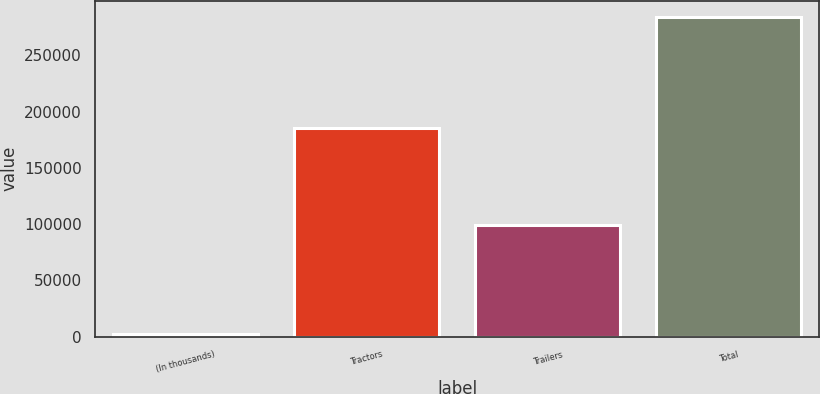Convert chart. <chart><loc_0><loc_0><loc_500><loc_500><bar_chart><fcel>(In thousands)<fcel>Tractors<fcel>Trailers<fcel>Total<nl><fcel>2018<fcel>185209<fcel>98835<fcel>284044<nl></chart> 